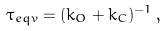<formula> <loc_0><loc_0><loc_500><loc_500>\tau _ { e q v } = ( k _ { O } + k _ { C } ) ^ { - 1 } \, ,</formula> 